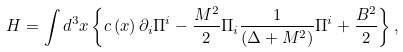<formula> <loc_0><loc_0><loc_500><loc_500>H = \int { d ^ { 3 } x } \left \{ { c \left ( x \right ) \partial _ { i } \Pi ^ { i } - \frac { M ^ { 2 } } { 2 } \Pi _ { i } \frac { 1 } { { \left ( { \Delta + M ^ { 2 } } \right ) } } \Pi ^ { i } + \frac { { { B } ^ { 2 } } } { 2 } } \right \} ,</formula> 